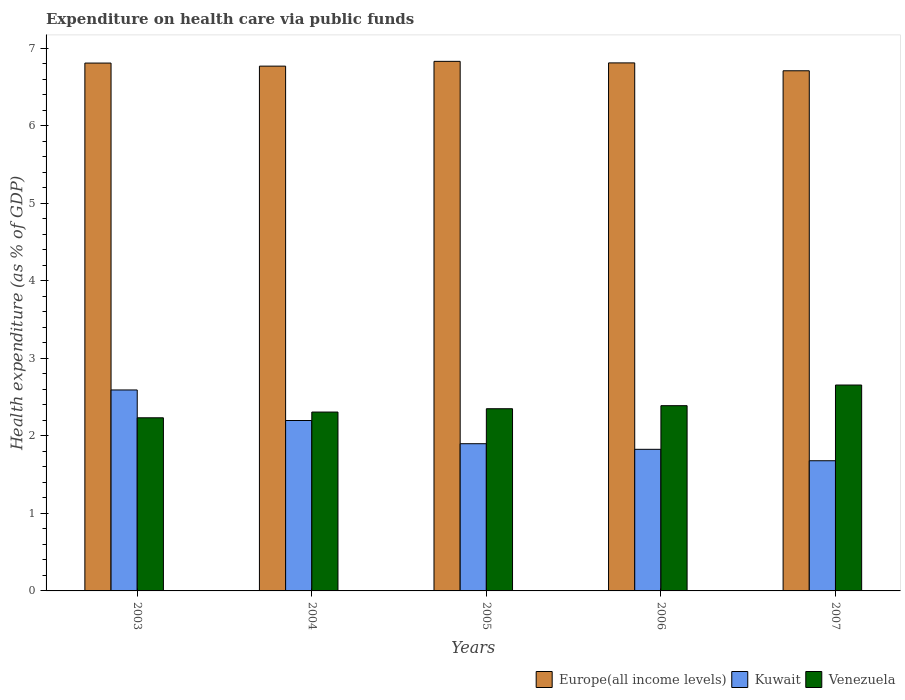Are the number of bars per tick equal to the number of legend labels?
Your answer should be very brief. Yes. How many bars are there on the 5th tick from the left?
Provide a succinct answer. 3. How many bars are there on the 3rd tick from the right?
Give a very brief answer. 3. In how many cases, is the number of bars for a given year not equal to the number of legend labels?
Offer a terse response. 0. What is the expenditure made on health care in Kuwait in 2006?
Offer a very short reply. 1.83. Across all years, what is the maximum expenditure made on health care in Kuwait?
Provide a short and direct response. 2.59. Across all years, what is the minimum expenditure made on health care in Kuwait?
Keep it short and to the point. 1.68. In which year was the expenditure made on health care in Europe(all income levels) maximum?
Provide a succinct answer. 2005. What is the total expenditure made on health care in Europe(all income levels) in the graph?
Your answer should be very brief. 33.92. What is the difference between the expenditure made on health care in Venezuela in 2004 and that in 2005?
Ensure brevity in your answer.  -0.04. What is the difference between the expenditure made on health care in Kuwait in 2007 and the expenditure made on health care in Venezuela in 2006?
Keep it short and to the point. -0.71. What is the average expenditure made on health care in Venezuela per year?
Give a very brief answer. 2.39. In the year 2006, what is the difference between the expenditure made on health care in Venezuela and expenditure made on health care in Kuwait?
Provide a short and direct response. 0.56. In how many years, is the expenditure made on health care in Venezuela greater than 0.8 %?
Your answer should be compact. 5. What is the ratio of the expenditure made on health care in Europe(all income levels) in 2003 to that in 2007?
Provide a succinct answer. 1.01. Is the difference between the expenditure made on health care in Venezuela in 2003 and 2005 greater than the difference between the expenditure made on health care in Kuwait in 2003 and 2005?
Give a very brief answer. No. What is the difference between the highest and the second highest expenditure made on health care in Venezuela?
Ensure brevity in your answer.  0.27. What is the difference between the highest and the lowest expenditure made on health care in Kuwait?
Keep it short and to the point. 0.91. Is the sum of the expenditure made on health care in Europe(all income levels) in 2004 and 2006 greater than the maximum expenditure made on health care in Kuwait across all years?
Keep it short and to the point. Yes. What does the 2nd bar from the left in 2006 represents?
Keep it short and to the point. Kuwait. What does the 2nd bar from the right in 2003 represents?
Offer a terse response. Kuwait. How many bars are there?
Offer a terse response. 15. Are all the bars in the graph horizontal?
Offer a terse response. No. What is the difference between two consecutive major ticks on the Y-axis?
Keep it short and to the point. 1. Are the values on the major ticks of Y-axis written in scientific E-notation?
Provide a succinct answer. No. How are the legend labels stacked?
Keep it short and to the point. Horizontal. What is the title of the graph?
Your answer should be very brief. Expenditure on health care via public funds. Does "Russian Federation" appear as one of the legend labels in the graph?
Your response must be concise. No. What is the label or title of the Y-axis?
Your answer should be very brief. Health expenditure (as % of GDP). What is the Health expenditure (as % of GDP) of Europe(all income levels) in 2003?
Give a very brief answer. 6.81. What is the Health expenditure (as % of GDP) of Kuwait in 2003?
Ensure brevity in your answer.  2.59. What is the Health expenditure (as % of GDP) in Venezuela in 2003?
Your answer should be very brief. 2.23. What is the Health expenditure (as % of GDP) of Europe(all income levels) in 2004?
Ensure brevity in your answer.  6.77. What is the Health expenditure (as % of GDP) of Kuwait in 2004?
Your answer should be compact. 2.2. What is the Health expenditure (as % of GDP) of Venezuela in 2004?
Provide a succinct answer. 2.31. What is the Health expenditure (as % of GDP) in Europe(all income levels) in 2005?
Keep it short and to the point. 6.83. What is the Health expenditure (as % of GDP) in Kuwait in 2005?
Your answer should be very brief. 1.9. What is the Health expenditure (as % of GDP) in Venezuela in 2005?
Give a very brief answer. 2.35. What is the Health expenditure (as % of GDP) in Europe(all income levels) in 2006?
Your answer should be very brief. 6.81. What is the Health expenditure (as % of GDP) of Kuwait in 2006?
Your answer should be compact. 1.83. What is the Health expenditure (as % of GDP) of Venezuela in 2006?
Offer a terse response. 2.39. What is the Health expenditure (as % of GDP) in Europe(all income levels) in 2007?
Your answer should be compact. 6.71. What is the Health expenditure (as % of GDP) in Kuwait in 2007?
Your answer should be compact. 1.68. What is the Health expenditure (as % of GDP) in Venezuela in 2007?
Your answer should be compact. 2.66. Across all years, what is the maximum Health expenditure (as % of GDP) of Europe(all income levels)?
Keep it short and to the point. 6.83. Across all years, what is the maximum Health expenditure (as % of GDP) of Kuwait?
Provide a succinct answer. 2.59. Across all years, what is the maximum Health expenditure (as % of GDP) in Venezuela?
Keep it short and to the point. 2.66. Across all years, what is the minimum Health expenditure (as % of GDP) in Europe(all income levels)?
Provide a short and direct response. 6.71. Across all years, what is the minimum Health expenditure (as % of GDP) in Kuwait?
Your answer should be very brief. 1.68. Across all years, what is the minimum Health expenditure (as % of GDP) in Venezuela?
Keep it short and to the point. 2.23. What is the total Health expenditure (as % of GDP) of Europe(all income levels) in the graph?
Provide a short and direct response. 33.92. What is the total Health expenditure (as % of GDP) in Kuwait in the graph?
Your answer should be very brief. 10.19. What is the total Health expenditure (as % of GDP) of Venezuela in the graph?
Provide a short and direct response. 11.93. What is the difference between the Health expenditure (as % of GDP) of Europe(all income levels) in 2003 and that in 2004?
Your response must be concise. 0.04. What is the difference between the Health expenditure (as % of GDP) of Kuwait in 2003 and that in 2004?
Provide a succinct answer. 0.39. What is the difference between the Health expenditure (as % of GDP) of Venezuela in 2003 and that in 2004?
Make the answer very short. -0.07. What is the difference between the Health expenditure (as % of GDP) of Europe(all income levels) in 2003 and that in 2005?
Your answer should be compact. -0.02. What is the difference between the Health expenditure (as % of GDP) in Kuwait in 2003 and that in 2005?
Offer a very short reply. 0.69. What is the difference between the Health expenditure (as % of GDP) of Venezuela in 2003 and that in 2005?
Your response must be concise. -0.12. What is the difference between the Health expenditure (as % of GDP) of Europe(all income levels) in 2003 and that in 2006?
Your response must be concise. -0. What is the difference between the Health expenditure (as % of GDP) of Kuwait in 2003 and that in 2006?
Provide a succinct answer. 0.77. What is the difference between the Health expenditure (as % of GDP) of Venezuela in 2003 and that in 2006?
Your answer should be compact. -0.16. What is the difference between the Health expenditure (as % of GDP) in Europe(all income levels) in 2003 and that in 2007?
Your answer should be compact. 0.1. What is the difference between the Health expenditure (as % of GDP) in Kuwait in 2003 and that in 2007?
Provide a succinct answer. 0.91. What is the difference between the Health expenditure (as % of GDP) in Venezuela in 2003 and that in 2007?
Offer a terse response. -0.42. What is the difference between the Health expenditure (as % of GDP) of Europe(all income levels) in 2004 and that in 2005?
Make the answer very short. -0.06. What is the difference between the Health expenditure (as % of GDP) in Kuwait in 2004 and that in 2005?
Provide a succinct answer. 0.3. What is the difference between the Health expenditure (as % of GDP) in Venezuela in 2004 and that in 2005?
Your answer should be compact. -0.04. What is the difference between the Health expenditure (as % of GDP) of Europe(all income levels) in 2004 and that in 2006?
Your answer should be very brief. -0.04. What is the difference between the Health expenditure (as % of GDP) in Kuwait in 2004 and that in 2006?
Your answer should be very brief. 0.37. What is the difference between the Health expenditure (as % of GDP) of Venezuela in 2004 and that in 2006?
Your response must be concise. -0.08. What is the difference between the Health expenditure (as % of GDP) of Europe(all income levels) in 2004 and that in 2007?
Provide a succinct answer. 0.06. What is the difference between the Health expenditure (as % of GDP) of Kuwait in 2004 and that in 2007?
Your answer should be very brief. 0.52. What is the difference between the Health expenditure (as % of GDP) in Venezuela in 2004 and that in 2007?
Offer a very short reply. -0.35. What is the difference between the Health expenditure (as % of GDP) of Europe(all income levels) in 2005 and that in 2006?
Ensure brevity in your answer.  0.02. What is the difference between the Health expenditure (as % of GDP) in Kuwait in 2005 and that in 2006?
Provide a succinct answer. 0.07. What is the difference between the Health expenditure (as % of GDP) of Venezuela in 2005 and that in 2006?
Your answer should be compact. -0.04. What is the difference between the Health expenditure (as % of GDP) in Europe(all income levels) in 2005 and that in 2007?
Offer a very short reply. 0.12. What is the difference between the Health expenditure (as % of GDP) in Kuwait in 2005 and that in 2007?
Offer a terse response. 0.22. What is the difference between the Health expenditure (as % of GDP) in Venezuela in 2005 and that in 2007?
Keep it short and to the point. -0.31. What is the difference between the Health expenditure (as % of GDP) of Europe(all income levels) in 2006 and that in 2007?
Make the answer very short. 0.1. What is the difference between the Health expenditure (as % of GDP) in Kuwait in 2006 and that in 2007?
Your answer should be compact. 0.15. What is the difference between the Health expenditure (as % of GDP) of Venezuela in 2006 and that in 2007?
Offer a terse response. -0.27. What is the difference between the Health expenditure (as % of GDP) of Europe(all income levels) in 2003 and the Health expenditure (as % of GDP) of Kuwait in 2004?
Give a very brief answer. 4.61. What is the difference between the Health expenditure (as % of GDP) in Europe(all income levels) in 2003 and the Health expenditure (as % of GDP) in Venezuela in 2004?
Your answer should be compact. 4.5. What is the difference between the Health expenditure (as % of GDP) in Kuwait in 2003 and the Health expenditure (as % of GDP) in Venezuela in 2004?
Ensure brevity in your answer.  0.28. What is the difference between the Health expenditure (as % of GDP) of Europe(all income levels) in 2003 and the Health expenditure (as % of GDP) of Kuwait in 2005?
Your answer should be compact. 4.91. What is the difference between the Health expenditure (as % of GDP) in Europe(all income levels) in 2003 and the Health expenditure (as % of GDP) in Venezuela in 2005?
Keep it short and to the point. 4.46. What is the difference between the Health expenditure (as % of GDP) of Kuwait in 2003 and the Health expenditure (as % of GDP) of Venezuela in 2005?
Keep it short and to the point. 0.24. What is the difference between the Health expenditure (as % of GDP) of Europe(all income levels) in 2003 and the Health expenditure (as % of GDP) of Kuwait in 2006?
Your answer should be compact. 4.98. What is the difference between the Health expenditure (as % of GDP) in Europe(all income levels) in 2003 and the Health expenditure (as % of GDP) in Venezuela in 2006?
Provide a succinct answer. 4.42. What is the difference between the Health expenditure (as % of GDP) in Kuwait in 2003 and the Health expenditure (as % of GDP) in Venezuela in 2006?
Your answer should be very brief. 0.2. What is the difference between the Health expenditure (as % of GDP) of Europe(all income levels) in 2003 and the Health expenditure (as % of GDP) of Kuwait in 2007?
Offer a terse response. 5.13. What is the difference between the Health expenditure (as % of GDP) in Europe(all income levels) in 2003 and the Health expenditure (as % of GDP) in Venezuela in 2007?
Keep it short and to the point. 4.15. What is the difference between the Health expenditure (as % of GDP) of Kuwait in 2003 and the Health expenditure (as % of GDP) of Venezuela in 2007?
Give a very brief answer. -0.06. What is the difference between the Health expenditure (as % of GDP) in Europe(all income levels) in 2004 and the Health expenditure (as % of GDP) in Kuwait in 2005?
Provide a short and direct response. 4.87. What is the difference between the Health expenditure (as % of GDP) of Europe(all income levels) in 2004 and the Health expenditure (as % of GDP) of Venezuela in 2005?
Your answer should be very brief. 4.42. What is the difference between the Health expenditure (as % of GDP) in Kuwait in 2004 and the Health expenditure (as % of GDP) in Venezuela in 2005?
Ensure brevity in your answer.  -0.15. What is the difference between the Health expenditure (as % of GDP) in Europe(all income levels) in 2004 and the Health expenditure (as % of GDP) in Kuwait in 2006?
Make the answer very short. 4.94. What is the difference between the Health expenditure (as % of GDP) in Europe(all income levels) in 2004 and the Health expenditure (as % of GDP) in Venezuela in 2006?
Your answer should be compact. 4.38. What is the difference between the Health expenditure (as % of GDP) of Kuwait in 2004 and the Health expenditure (as % of GDP) of Venezuela in 2006?
Your answer should be very brief. -0.19. What is the difference between the Health expenditure (as % of GDP) of Europe(all income levels) in 2004 and the Health expenditure (as % of GDP) of Kuwait in 2007?
Your answer should be compact. 5.09. What is the difference between the Health expenditure (as % of GDP) of Europe(all income levels) in 2004 and the Health expenditure (as % of GDP) of Venezuela in 2007?
Offer a terse response. 4.11. What is the difference between the Health expenditure (as % of GDP) of Kuwait in 2004 and the Health expenditure (as % of GDP) of Venezuela in 2007?
Provide a short and direct response. -0.46. What is the difference between the Health expenditure (as % of GDP) of Europe(all income levels) in 2005 and the Health expenditure (as % of GDP) of Kuwait in 2006?
Keep it short and to the point. 5. What is the difference between the Health expenditure (as % of GDP) in Europe(all income levels) in 2005 and the Health expenditure (as % of GDP) in Venezuela in 2006?
Make the answer very short. 4.44. What is the difference between the Health expenditure (as % of GDP) of Kuwait in 2005 and the Health expenditure (as % of GDP) of Venezuela in 2006?
Keep it short and to the point. -0.49. What is the difference between the Health expenditure (as % of GDP) of Europe(all income levels) in 2005 and the Health expenditure (as % of GDP) of Kuwait in 2007?
Make the answer very short. 5.15. What is the difference between the Health expenditure (as % of GDP) of Europe(all income levels) in 2005 and the Health expenditure (as % of GDP) of Venezuela in 2007?
Your response must be concise. 4.17. What is the difference between the Health expenditure (as % of GDP) in Kuwait in 2005 and the Health expenditure (as % of GDP) in Venezuela in 2007?
Give a very brief answer. -0.76. What is the difference between the Health expenditure (as % of GDP) in Europe(all income levels) in 2006 and the Health expenditure (as % of GDP) in Kuwait in 2007?
Your answer should be compact. 5.13. What is the difference between the Health expenditure (as % of GDP) in Europe(all income levels) in 2006 and the Health expenditure (as % of GDP) in Venezuela in 2007?
Give a very brief answer. 4.15. What is the difference between the Health expenditure (as % of GDP) in Kuwait in 2006 and the Health expenditure (as % of GDP) in Venezuela in 2007?
Make the answer very short. -0.83. What is the average Health expenditure (as % of GDP) of Europe(all income levels) per year?
Ensure brevity in your answer.  6.78. What is the average Health expenditure (as % of GDP) of Kuwait per year?
Your answer should be very brief. 2.04. What is the average Health expenditure (as % of GDP) in Venezuela per year?
Ensure brevity in your answer.  2.39. In the year 2003, what is the difference between the Health expenditure (as % of GDP) in Europe(all income levels) and Health expenditure (as % of GDP) in Kuwait?
Ensure brevity in your answer.  4.22. In the year 2003, what is the difference between the Health expenditure (as % of GDP) of Europe(all income levels) and Health expenditure (as % of GDP) of Venezuela?
Your answer should be very brief. 4.57. In the year 2003, what is the difference between the Health expenditure (as % of GDP) of Kuwait and Health expenditure (as % of GDP) of Venezuela?
Provide a succinct answer. 0.36. In the year 2004, what is the difference between the Health expenditure (as % of GDP) in Europe(all income levels) and Health expenditure (as % of GDP) in Kuwait?
Ensure brevity in your answer.  4.57. In the year 2004, what is the difference between the Health expenditure (as % of GDP) of Europe(all income levels) and Health expenditure (as % of GDP) of Venezuela?
Provide a succinct answer. 4.46. In the year 2004, what is the difference between the Health expenditure (as % of GDP) of Kuwait and Health expenditure (as % of GDP) of Venezuela?
Ensure brevity in your answer.  -0.11. In the year 2005, what is the difference between the Health expenditure (as % of GDP) of Europe(all income levels) and Health expenditure (as % of GDP) of Kuwait?
Your answer should be very brief. 4.93. In the year 2005, what is the difference between the Health expenditure (as % of GDP) of Europe(all income levels) and Health expenditure (as % of GDP) of Venezuela?
Offer a terse response. 4.48. In the year 2005, what is the difference between the Health expenditure (as % of GDP) of Kuwait and Health expenditure (as % of GDP) of Venezuela?
Provide a succinct answer. -0.45. In the year 2006, what is the difference between the Health expenditure (as % of GDP) in Europe(all income levels) and Health expenditure (as % of GDP) in Kuwait?
Make the answer very short. 4.98. In the year 2006, what is the difference between the Health expenditure (as % of GDP) in Europe(all income levels) and Health expenditure (as % of GDP) in Venezuela?
Offer a terse response. 4.42. In the year 2006, what is the difference between the Health expenditure (as % of GDP) in Kuwait and Health expenditure (as % of GDP) in Venezuela?
Make the answer very short. -0.56. In the year 2007, what is the difference between the Health expenditure (as % of GDP) in Europe(all income levels) and Health expenditure (as % of GDP) in Kuwait?
Your response must be concise. 5.03. In the year 2007, what is the difference between the Health expenditure (as % of GDP) in Europe(all income levels) and Health expenditure (as % of GDP) in Venezuela?
Give a very brief answer. 4.05. In the year 2007, what is the difference between the Health expenditure (as % of GDP) in Kuwait and Health expenditure (as % of GDP) in Venezuela?
Keep it short and to the point. -0.98. What is the ratio of the Health expenditure (as % of GDP) of Europe(all income levels) in 2003 to that in 2004?
Provide a short and direct response. 1.01. What is the ratio of the Health expenditure (as % of GDP) in Kuwait in 2003 to that in 2004?
Offer a terse response. 1.18. What is the ratio of the Health expenditure (as % of GDP) of Venezuela in 2003 to that in 2004?
Your answer should be very brief. 0.97. What is the ratio of the Health expenditure (as % of GDP) in Kuwait in 2003 to that in 2005?
Give a very brief answer. 1.37. What is the ratio of the Health expenditure (as % of GDP) in Venezuela in 2003 to that in 2005?
Provide a short and direct response. 0.95. What is the ratio of the Health expenditure (as % of GDP) in Kuwait in 2003 to that in 2006?
Keep it short and to the point. 1.42. What is the ratio of the Health expenditure (as % of GDP) in Venezuela in 2003 to that in 2006?
Your answer should be very brief. 0.93. What is the ratio of the Health expenditure (as % of GDP) of Europe(all income levels) in 2003 to that in 2007?
Keep it short and to the point. 1.01. What is the ratio of the Health expenditure (as % of GDP) of Kuwait in 2003 to that in 2007?
Your answer should be compact. 1.54. What is the ratio of the Health expenditure (as % of GDP) in Venezuela in 2003 to that in 2007?
Your answer should be compact. 0.84. What is the ratio of the Health expenditure (as % of GDP) in Kuwait in 2004 to that in 2005?
Make the answer very short. 1.16. What is the ratio of the Health expenditure (as % of GDP) in Venezuela in 2004 to that in 2005?
Make the answer very short. 0.98. What is the ratio of the Health expenditure (as % of GDP) in Europe(all income levels) in 2004 to that in 2006?
Ensure brevity in your answer.  0.99. What is the ratio of the Health expenditure (as % of GDP) in Kuwait in 2004 to that in 2006?
Ensure brevity in your answer.  1.2. What is the ratio of the Health expenditure (as % of GDP) of Venezuela in 2004 to that in 2006?
Make the answer very short. 0.97. What is the ratio of the Health expenditure (as % of GDP) in Europe(all income levels) in 2004 to that in 2007?
Provide a succinct answer. 1.01. What is the ratio of the Health expenditure (as % of GDP) in Kuwait in 2004 to that in 2007?
Offer a terse response. 1.31. What is the ratio of the Health expenditure (as % of GDP) of Venezuela in 2004 to that in 2007?
Make the answer very short. 0.87. What is the ratio of the Health expenditure (as % of GDP) of Europe(all income levels) in 2005 to that in 2006?
Make the answer very short. 1. What is the ratio of the Health expenditure (as % of GDP) of Kuwait in 2005 to that in 2006?
Your answer should be very brief. 1.04. What is the ratio of the Health expenditure (as % of GDP) of Venezuela in 2005 to that in 2006?
Your answer should be compact. 0.98. What is the ratio of the Health expenditure (as % of GDP) in Europe(all income levels) in 2005 to that in 2007?
Your answer should be compact. 1.02. What is the ratio of the Health expenditure (as % of GDP) in Kuwait in 2005 to that in 2007?
Your answer should be very brief. 1.13. What is the ratio of the Health expenditure (as % of GDP) in Venezuela in 2005 to that in 2007?
Your answer should be compact. 0.88. What is the ratio of the Health expenditure (as % of GDP) in Europe(all income levels) in 2006 to that in 2007?
Provide a short and direct response. 1.02. What is the ratio of the Health expenditure (as % of GDP) of Kuwait in 2006 to that in 2007?
Your answer should be compact. 1.09. What is the ratio of the Health expenditure (as % of GDP) of Venezuela in 2006 to that in 2007?
Give a very brief answer. 0.9. What is the difference between the highest and the second highest Health expenditure (as % of GDP) of Europe(all income levels)?
Offer a terse response. 0.02. What is the difference between the highest and the second highest Health expenditure (as % of GDP) of Kuwait?
Provide a short and direct response. 0.39. What is the difference between the highest and the second highest Health expenditure (as % of GDP) of Venezuela?
Provide a short and direct response. 0.27. What is the difference between the highest and the lowest Health expenditure (as % of GDP) in Europe(all income levels)?
Give a very brief answer. 0.12. What is the difference between the highest and the lowest Health expenditure (as % of GDP) in Kuwait?
Make the answer very short. 0.91. What is the difference between the highest and the lowest Health expenditure (as % of GDP) in Venezuela?
Your answer should be compact. 0.42. 